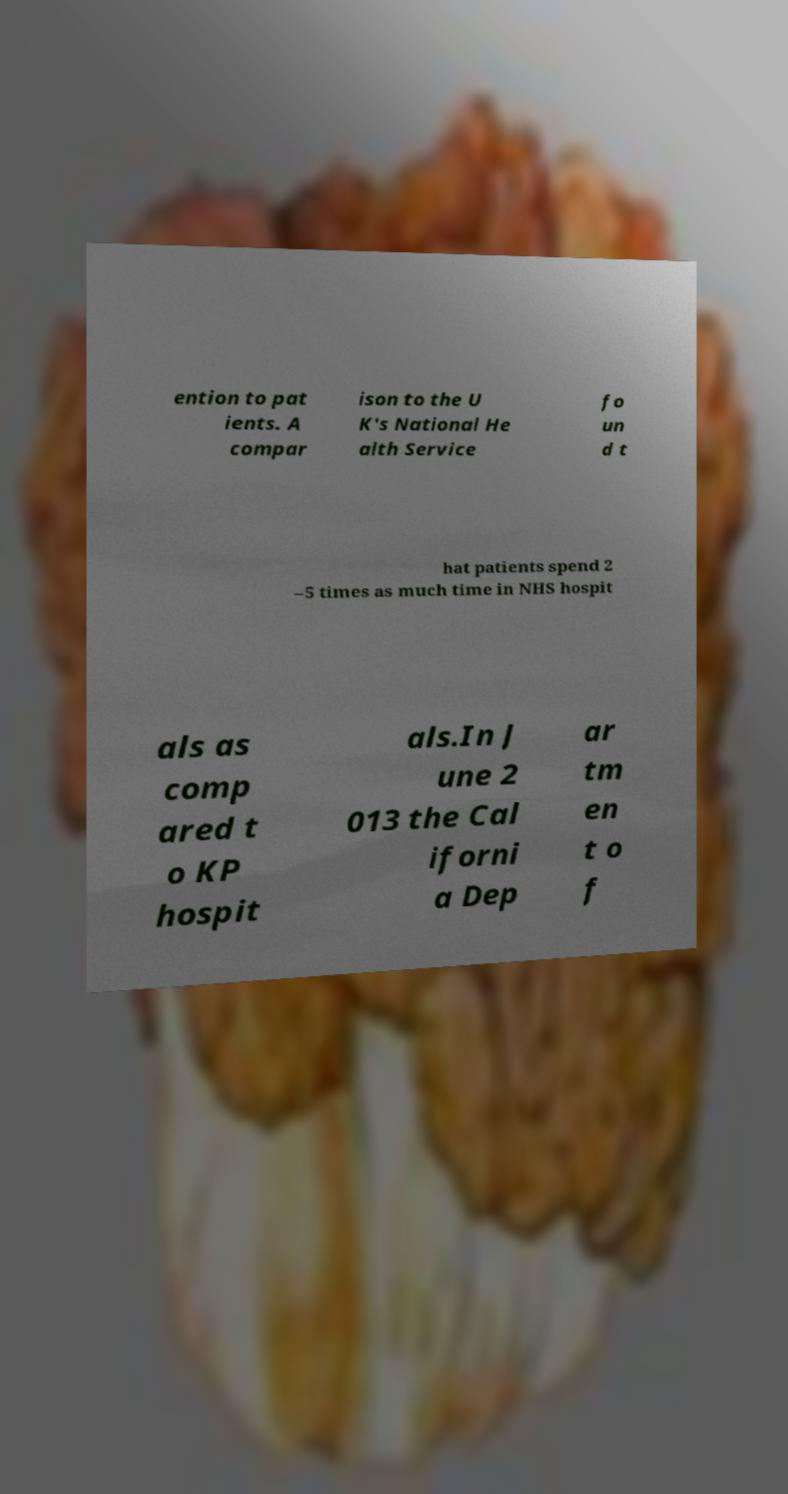For documentation purposes, I need the text within this image transcribed. Could you provide that? ention to pat ients. A compar ison to the U K's National He alth Service fo un d t hat patients spend 2 –5 times as much time in NHS hospit als as comp ared t o KP hospit als.In J une 2 013 the Cal iforni a Dep ar tm en t o f 